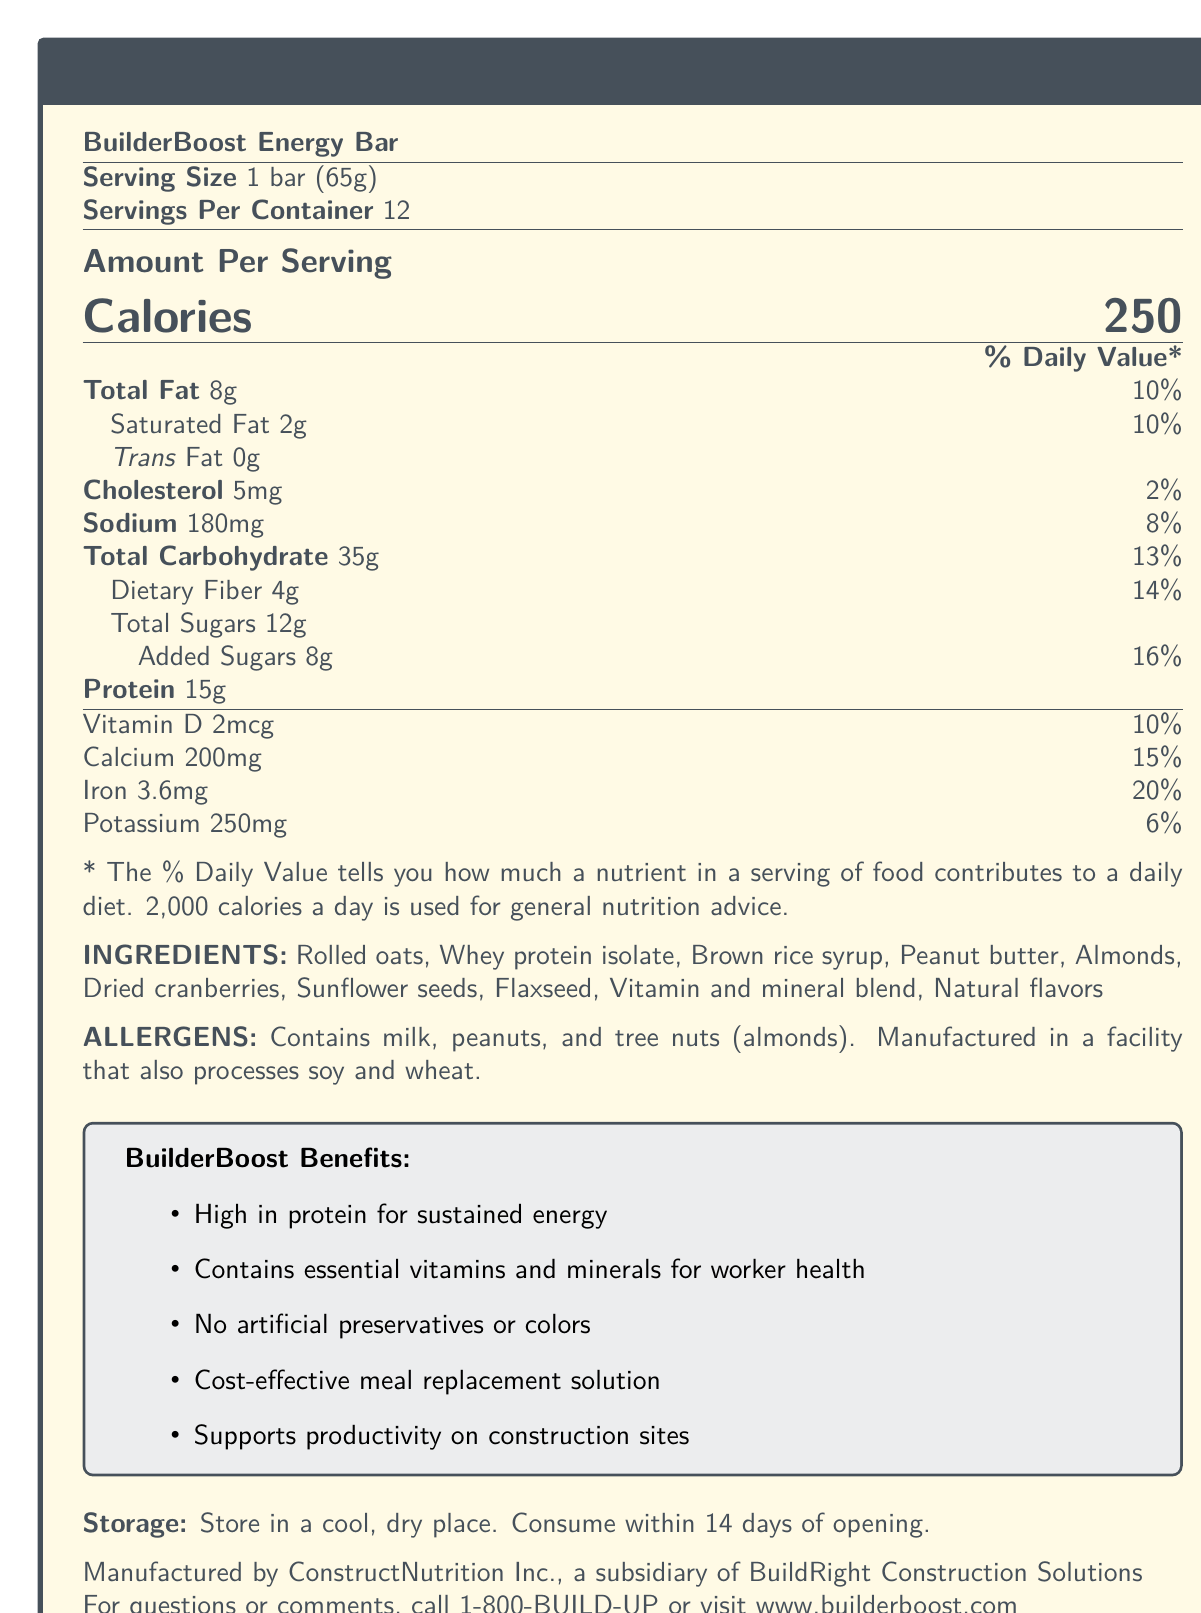what is the serving size of the BuilderBoost Energy Bar? The document specifies the serving size as "1 bar (65g)".
Answer: 1 bar (65g) how many servings are there per container? The document mentions that there are 12 servings per container.
Answer: 12 how many grams of protein are in one bar? The amount of protein per serving is listed as 15g.
Answer: 15g list three main ingredients found in the BuilderBoost Energy Bar. These ingredients are listed first among the ingredients.
Answer: Rolled oats, Whey protein isolate, Peanut butter what is the amount of total carbohydrates in one bar? The document states the total carbohydrate content per serving as 35g.
Answer: 35g which statement is true about the allergens in the BuilderBoost Energy Bar? A. Contains soy and wheat B. Contains milk and peanuts C. Contains fish and shellfish The allergens specified are milk, peanuts, and tree nuts (almonds).
Answer: B how much iron does one bar contain? A. 10% of daily value B. 15% of daily value C. 20% of daily value The document states that one bar contains 20% of the daily value of iron.
Answer: C are there any artificial preservatives in the BuilderBoost Energy Bar? The document claims "No artificial preservatives or colors".
Answer: No is the BuilderBoost Energy Bar marketed as a cost-effective meal replacement solution? One of the marketing claims is that it is a cost-effective meal replacement solution.
Answer: Yes summarize the main benefits of the BuilderBoost Energy Bar. These benefits are listed under the "BuilderBoost Benefits" section.
Answer: High in protein for sustained energy, Contains essential vitamins and minerals for worker health, No artificial preservatives or colors, Cost-effective meal replacement solution, Supports productivity on construction sites list the vitamins and minerals mentioned in the document along with their amounts and daily values. The "Amount Per Serving" detailed table includes these vitamins and minerals along with their amounts and daily values.
Answer: Vitamin D: 2mcg (10%), Calcium: 200mg (15%), Iron: 3.6mg (20%), Potassium: 250mg (6%) where should the BuilderBoost Energy Bar be stored? The storage instructions state to store it in a cool, dry place.
Answer: In a cool, dry place how long should the bar be consumed after opening? The storage instructions specify consumption within 14 days of opening.
Answer: Within 14 days is the BuilderBoost Energy Bar manufactured in a facility that processes soy and wheat? The allergens section states it is manufactured in a facility that also processes soy and wheat.
Answer: Yes what is the daily value percentage of added sugars in the bar? The daily value percentage for added sugars is listed as 16%.
Answer: 16% how many calories are in one bar of BuilderBoost? The document lists 250 as the calories per serving.
Answer: 250 calories can the exact cost of the BuilderBoost Energy Bar be determined from this document? The document does not provide any cost-related information.
Answer: Not enough information 